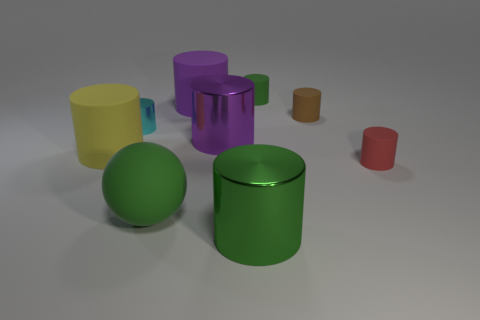Does the tiny red matte thing have the same shape as the tiny shiny object? Yes, both the tiny red matte object and the tiny shiny object appear to have cylindrical shapes with circular bases, although they differ in size and texture. 